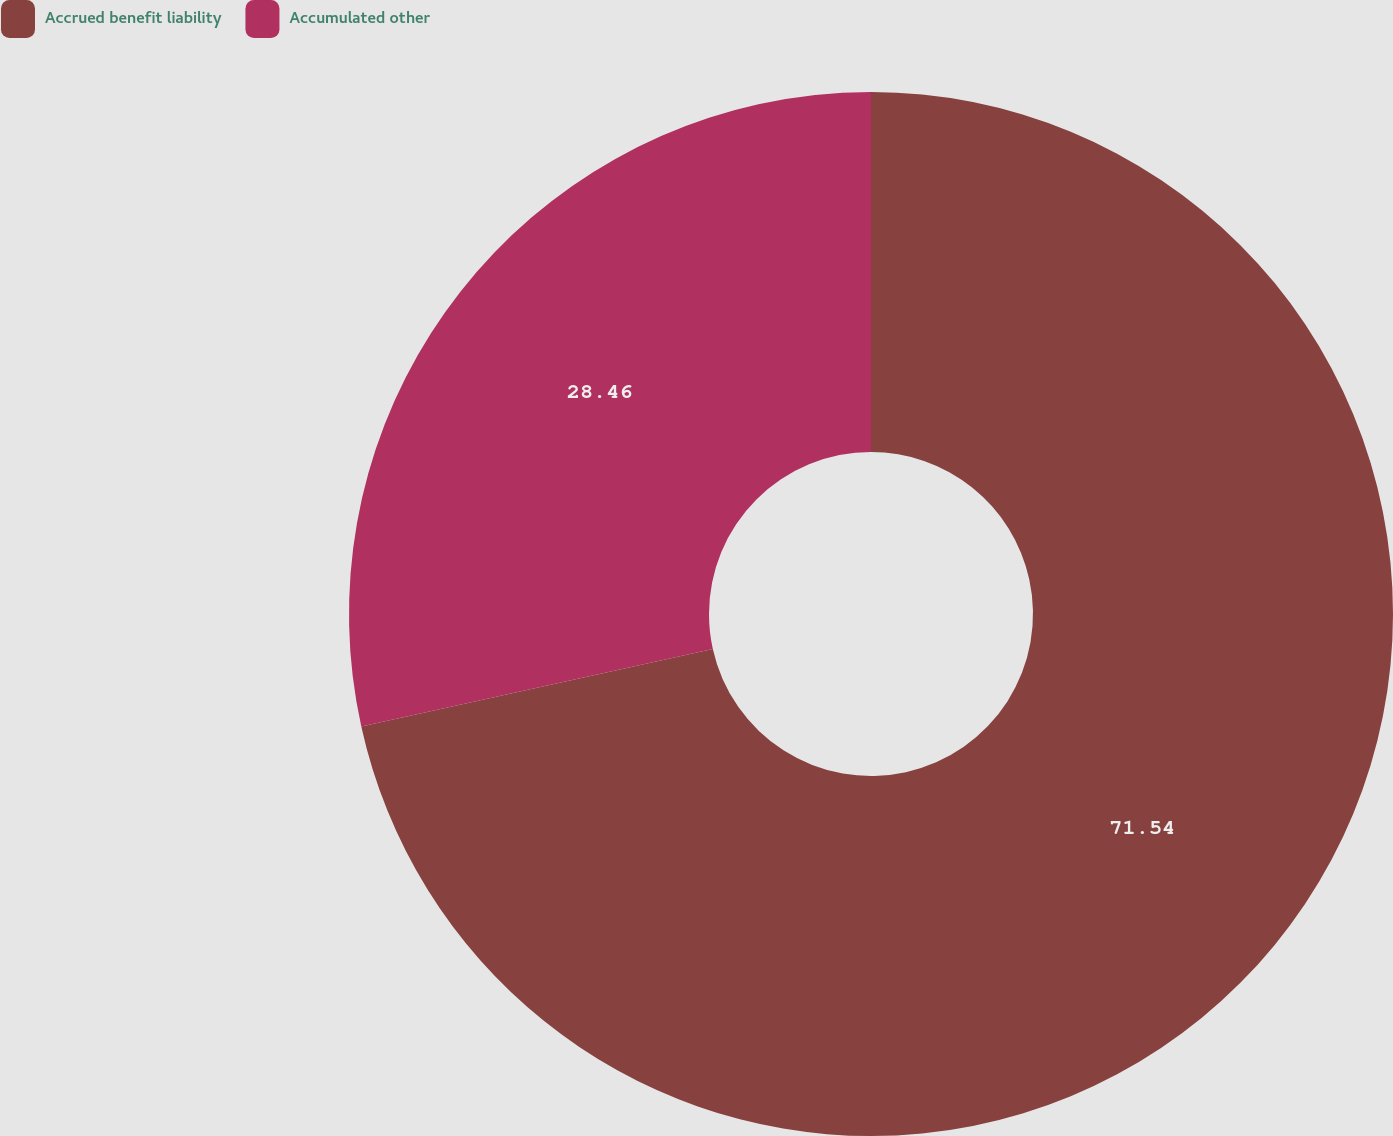Convert chart. <chart><loc_0><loc_0><loc_500><loc_500><pie_chart><fcel>Accrued benefit liability<fcel>Accumulated other<nl><fcel>71.54%<fcel>28.46%<nl></chart> 